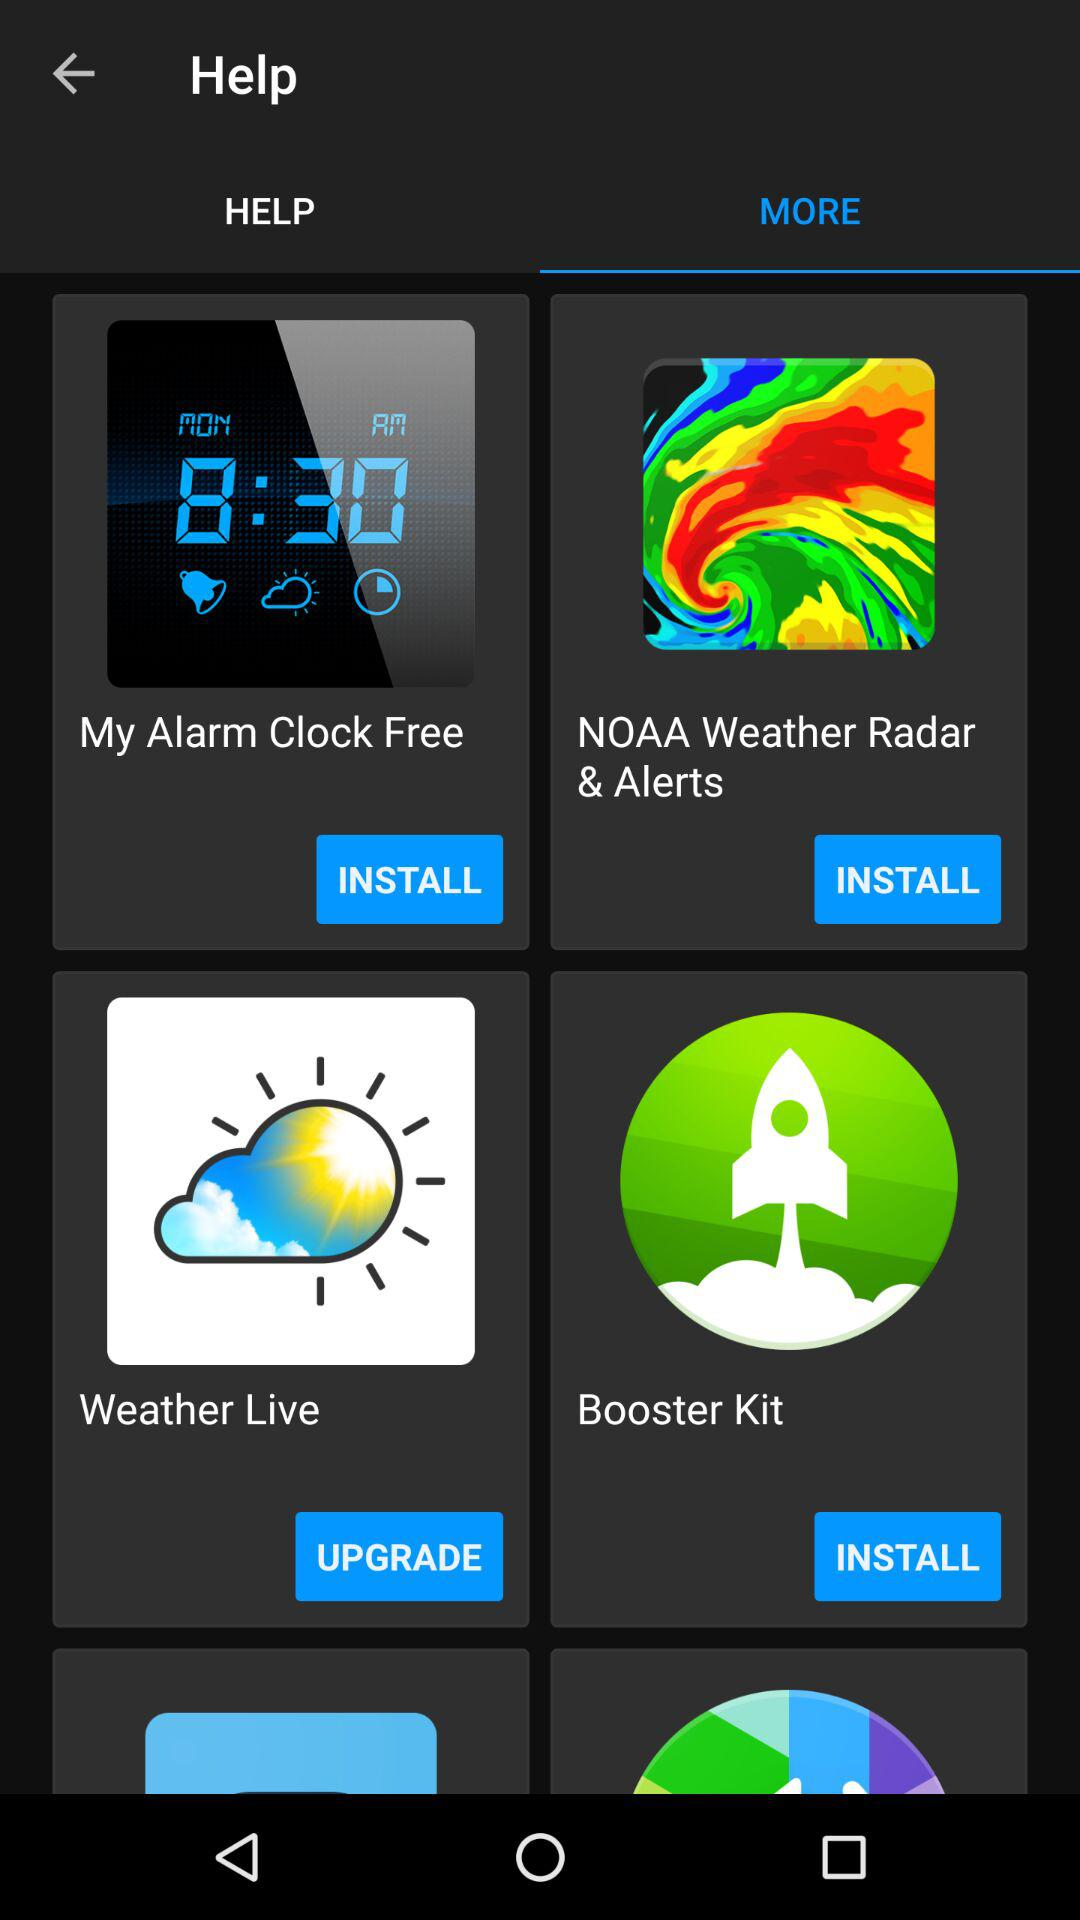Which tab am I on? You are on the "MORE" tab. 